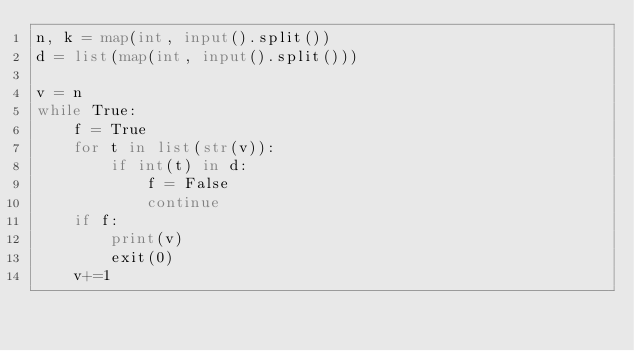<code> <loc_0><loc_0><loc_500><loc_500><_Python_>n, k = map(int, input().split())
d = list(map(int, input().split()))

v = n
while True:
    f = True
    for t in list(str(v)):
        if int(t) in d:
            f = False
            continue
    if f:
        print(v)
        exit(0)
    v+=1
</code> 